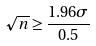<formula> <loc_0><loc_0><loc_500><loc_500>\sqrt { n } \geq \frac { 1 . 9 6 \sigma } { 0 . 5 }</formula> 